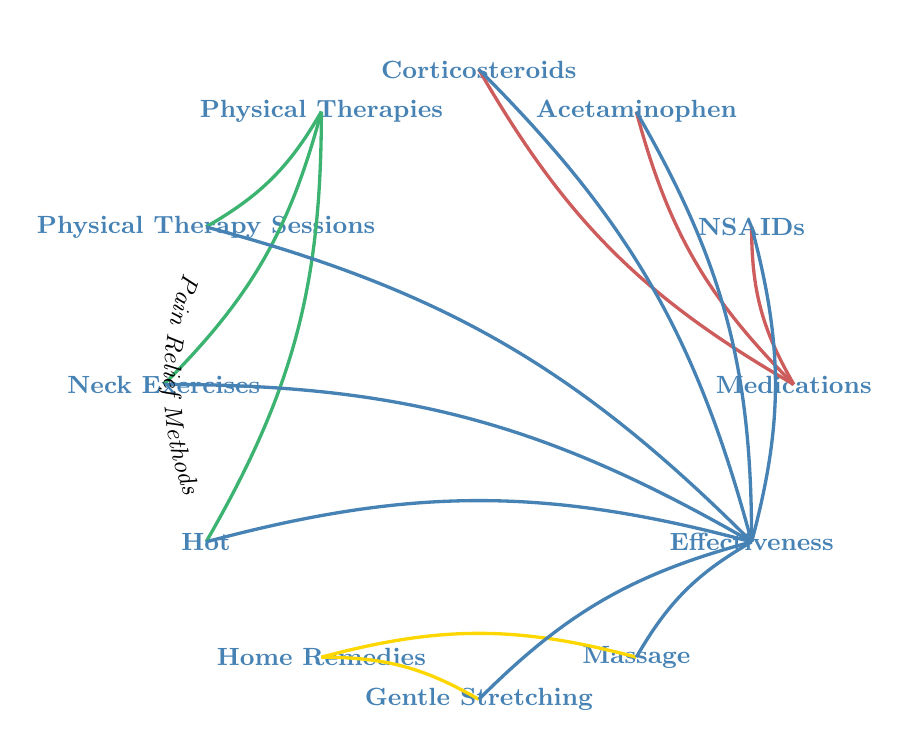What are the three main categories of pain relief methods in this diagram? The diagram displays three main categories: Medications, Physical Therapies, and Home Remedies. These are the primary segments that represent various nodes connected to pain relief methods.
Answer: Medications, Physical Therapies, Home Remedies How many total nodes are shown in the diagram? By counting each category and its connected methods, there are a total of 12 nodes represented in the diagram. Each node represents either a type of pain relief method or an aspect related to effectiveness.
Answer: 12 Which method is connected to both Medications and Effectiveness? NSAIDs is the method connected to both Medications (as one of the types of medications) and Effectiveness (indicating its impact on pain management).
Answer: NSAIDs What are two home remedies connected to Effectiveness? Gentle Stretching and Massage are the two home remedies connected to Effectiveness in the diagram. Both remedies aim to alleviate pain while being categorized under home remedies.
Answer: Gentle Stretching, Massage Which physical therapy method connects to Effectiveness? There are three physical therapy methods connected to Effectiveness: Physical Therapy Sessions, Neck Exercises, and Hot/Cold Therapy. Each method is associated with a direct benefit to managing pain.
Answer: Physical Therapy Sessions, Neck Exercises, Hot/Cold Therapy How many connections arise from Home Remedies? The Home Remedies node has two connections: one to Gentle Stretching and another to Massage, indicating two methods that fall under home remedies in the context of effectiveness.
Answer: 2 Which medication method shows a direct link to Effectiveness? The three medication methods connected to Effectiveness are NSAIDs, Acetaminophen, and Corticosteroids. Each type of medication impacts overall effectiveness in pain relief strategies.
Answer: NSAIDs, Acetaminophen, Corticosteroids What is the relationship between Physical Therapies and Effectiveness? Physical Therapies have three methods that connect to Effectiveness (Physical Therapy Sessions, Neck Exercises, Hot/Cold Therapy). This denotes that these approaches are evaluated based on how effective they are in alleviating pain.
Answer: Physical Therapies connect to Effectiveness through three methods 